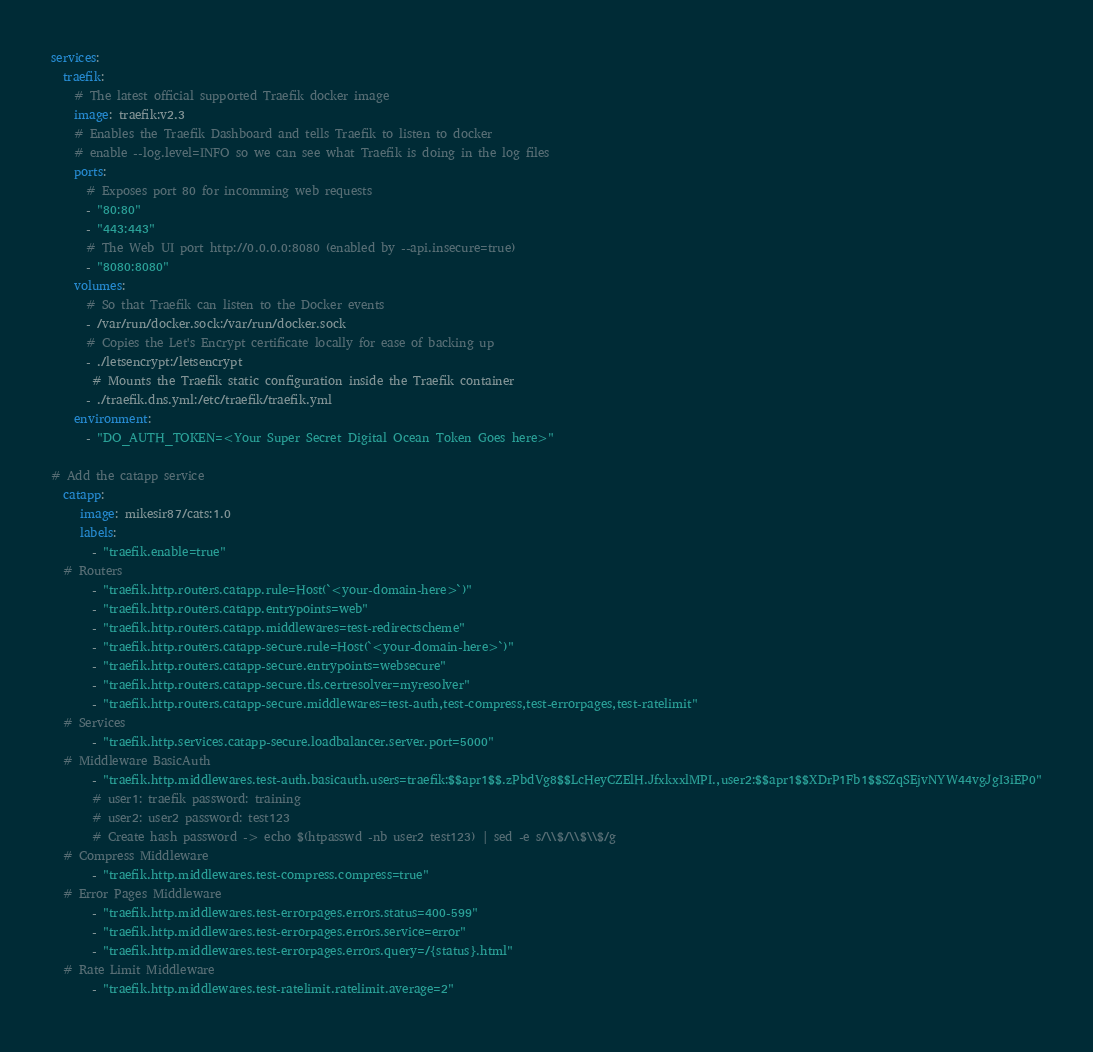<code> <loc_0><loc_0><loc_500><loc_500><_YAML_>services:
  traefik:
    # The latest official supported Traefik docker image
    image: traefik:v2.3
    # Enables the Traefik Dashboard and tells Traefik to listen to docker
    # enable --log.level=INFO so we can see what Traefik is doing in the log files
    ports:
      # Exposes port 80 for incomming web requests
      - "80:80"
      - "443:443"
      # The Web UI port http://0.0.0.0:8080 (enabled by --api.insecure=true)
      - "8080:8080"
    volumes:
      # So that Traefik can listen to the Docker events
      - /var/run/docker.sock:/var/run/docker.sock
      # Copies the Let's Encrypt certificate locally for ease of backing up
      - ./letsencrypt:/letsencrypt
       # Mounts the Traefik static configuration inside the Traefik container
      - ./traefik.dns.yml:/etc/traefik/traefik.yml
    environment:
      - "DO_AUTH_TOKEN=<Your Super Secret Digital Ocean Token Goes here>"

# Add the catapp service
  catapp:
     image: mikesir87/cats:1.0
     labels:
       - "traefik.enable=true"
  # Routers
       - "traefik.http.routers.catapp.rule=Host(`<your-domain-here>`)"
       - "traefik.http.routers.catapp.entrypoints=web"
       - "traefik.http.routers.catapp.middlewares=test-redirectscheme"
       - "traefik.http.routers.catapp-secure.rule=Host(`<your-domain-here>`)"
       - "traefik.http.routers.catapp-secure.entrypoints=websecure"
       - "traefik.http.routers.catapp-secure.tls.certresolver=myresolver"
       - "traefik.http.routers.catapp-secure.middlewares=test-auth,test-compress,test-errorpages,test-ratelimit"
  # Services
       - "traefik.http.services.catapp-secure.loadbalancer.server.port=5000"
  # Middleware BasicAuth
       - "traefik.http.middlewares.test-auth.basicauth.users=traefik:$$apr1$$.zPbdVg8$$LcHeyCZElH.JfxkxxlMPI.,user2:$$apr1$$XDrP1Fb1$$SZqSEjvNYW44vgJgI3iEP0"
       # user1: traefik password: training
       # user2: user2 password: test123
       # Create hash password -> echo $(htpasswd -nb user2 test123) | sed -e s/\\$/\\$\\$/g
  # Compress Middleware
       - "traefik.http.middlewares.test-compress.compress=true"
  # Error Pages Middleware
       - "traefik.http.middlewares.test-errorpages.errors.status=400-599"
       - "traefik.http.middlewares.test-errorpages.errors.service=error"
       - "traefik.http.middlewares.test-errorpages.errors.query=/{status}.html"
  # Rate Limit Middleware
       - "traefik.http.middlewares.test-ratelimit.ratelimit.average=2"</code> 